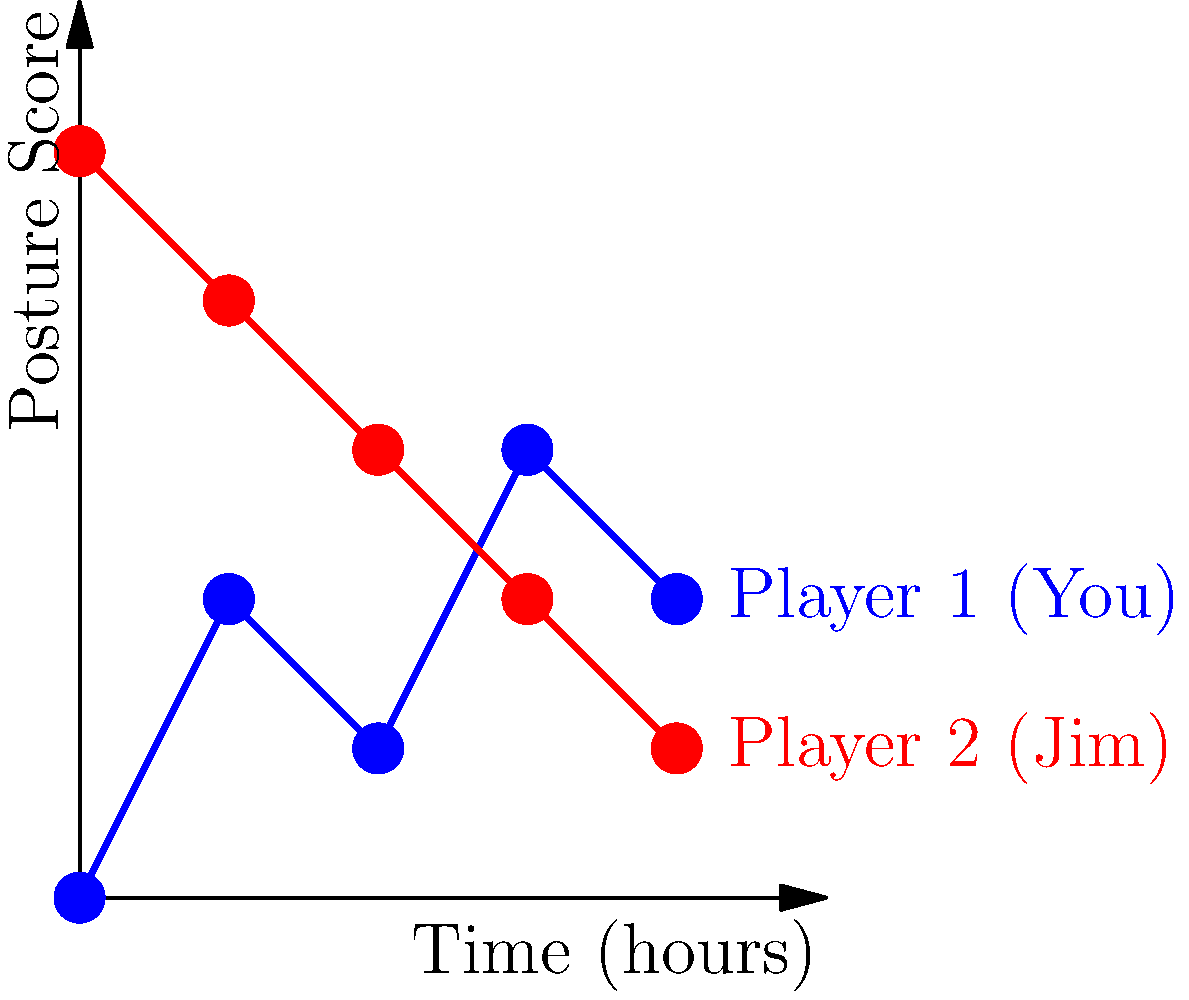Based on the posture analysis graphics shown above, which player is likely experiencing more fatigue as the match progresses? To determine which player is experiencing more fatigue, we need to analyze the posture scores over time for both players:

1. Interpret the graph:
   - The x-axis represents time (in hours) during the match.
   - The y-axis represents the posture score, where a higher score indicates better posture.

2. Analyze Player 1 (You):
   - Starting posture score: 0
   - Ending posture score: 2
   - Overall trend: Slightly increasing with some fluctuations

3. Analyze Player 2 (Jim):
   - Starting posture score: 5
   - Ending posture score: 1
   - Overall trend: Steadily decreasing

4. Compare the trends:
   - Player 1's posture score shows a slight improvement over time.
   - Player 2's posture score consistently decreases throughout the match.

5. Conclusion:
   A decreasing posture score over time is typically associated with increasing fatigue. Player 2 (Jim) shows a clear downward trend in posture score, indicating that he is likely experiencing more fatigue as the match progresses.
Answer: Player 2 (Jim) 